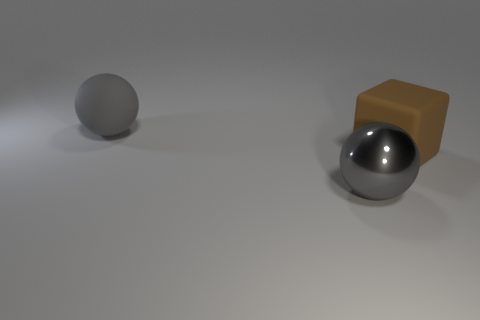Is the big sphere behind the large brown object made of the same material as the block?
Ensure brevity in your answer.  Yes. There is a thing that is both in front of the big rubber sphere and to the left of the brown block; what material is it?
Your answer should be very brief. Metal. There is a sphere on the left side of the sphere that is in front of the big block; what color is it?
Make the answer very short. Gray. What material is the other big gray thing that is the same shape as the gray shiny object?
Offer a terse response. Rubber. The big rubber thing that is in front of the sphere that is on the left side of the gray object that is in front of the brown block is what color?
Keep it short and to the point. Brown. Is the material of the brown block the same as the gray sphere that is behind the large matte block?
Your answer should be compact. Yes. What is the size of the gray object that is made of the same material as the large brown thing?
Your answer should be very brief. Large. There is a gray object in front of the gray rubber ball; how big is it?
Provide a succinct answer. Large. What is the color of the shiny sphere that is the same size as the cube?
Provide a succinct answer. Gray. There is a metal ball; does it have the same color as the large sphere that is behind the big cube?
Give a very brief answer. Yes. 